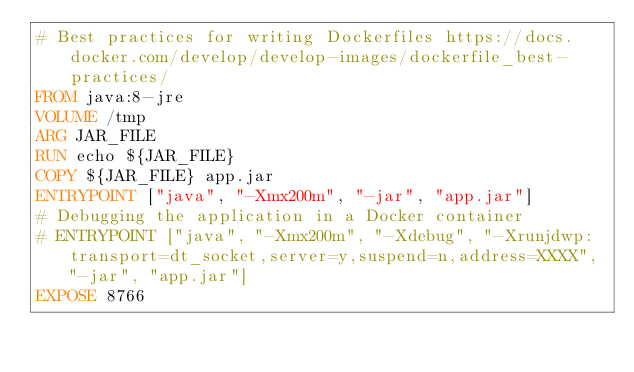Convert code to text. <code><loc_0><loc_0><loc_500><loc_500><_Dockerfile_># Best practices for writing Dockerfiles https://docs.docker.com/develop/develop-images/dockerfile_best-practices/
FROM java:8-jre
VOLUME /tmp
ARG JAR_FILE
RUN echo ${JAR_FILE}
COPY ${JAR_FILE} app.jar
ENTRYPOINT ["java", "-Xmx200m", "-jar", "app.jar"]
# Debugging the application in a Docker container
# ENTRYPOINT ["java", "-Xmx200m", "-Xdebug", "-Xrunjdwp:transport=dt_socket,server=y,suspend=n,address=XXXX", "-jar", "app.jar"]
EXPOSE 8766
</code> 